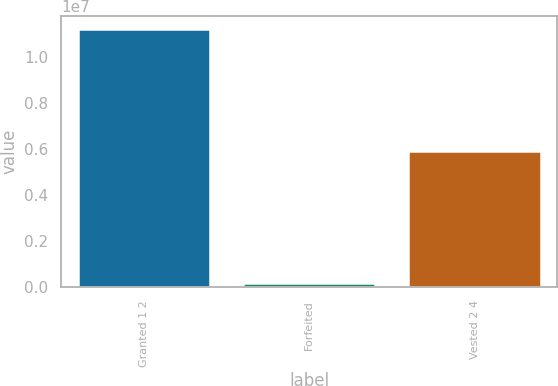Convert chart to OTSL. <chart><loc_0><loc_0><loc_500><loc_500><bar_chart><fcel>Granted 1 2<fcel>Forfeited<fcel>Vested 2 4<nl><fcel>1.12268e+07<fcel>152194<fcel>5.90769e+06<nl></chart> 